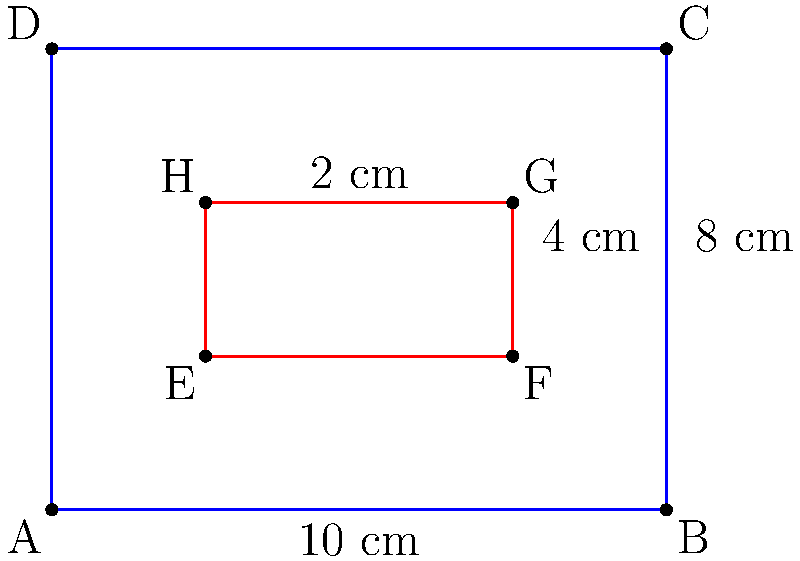As part of a neuroscience experiment, you're tasked with determining the area of overlap between two rectangular EEG sensor placements. The outer rectangle (blue) represents the full scalp area, measuring 10 cm by 8 cm. The inner rectangle (red) represents a specific sensor array, measuring 4 cm by 2 cm. If the inner rectangle is centered within the outer rectangle, what is the area of the inner rectangle in square centimeters? To solve this problem, we need to follow these steps:

1. Identify the dimensions of the inner rectangle (red):
   - Width = 4 cm
   - Height = 2 cm

2. Calculate the area of a rectangle using the formula:
   $$ A = w \times h $$
   Where:
   $A$ = Area
   $w$ = Width
   $h$ = Height

3. Plug in the values:
   $$ A = 4 \text{ cm} \times 2 \text{ cm} $$

4. Perform the multiplication:
   $$ A = 8 \text{ cm}^2 $$

Therefore, the area of the inner rectangle (red) representing the specific sensor array is 8 square centimeters.
Answer: $8 \text{ cm}^2$ 